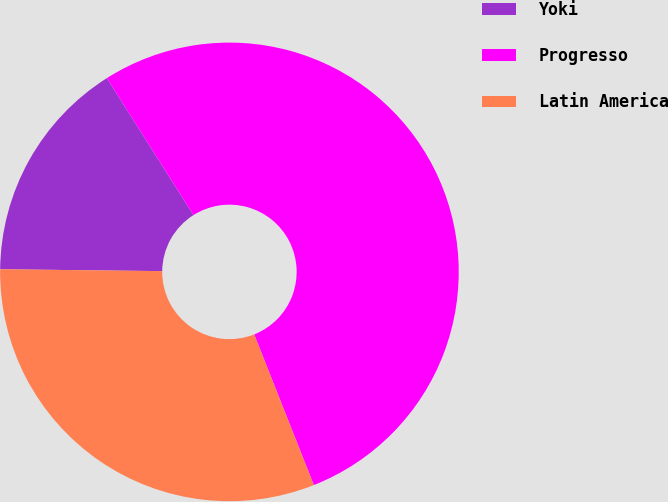Convert chart. <chart><loc_0><loc_0><loc_500><loc_500><pie_chart><fcel>Yoki<fcel>Progresso<fcel>Latin America<nl><fcel>15.84%<fcel>52.97%<fcel>31.18%<nl></chart> 